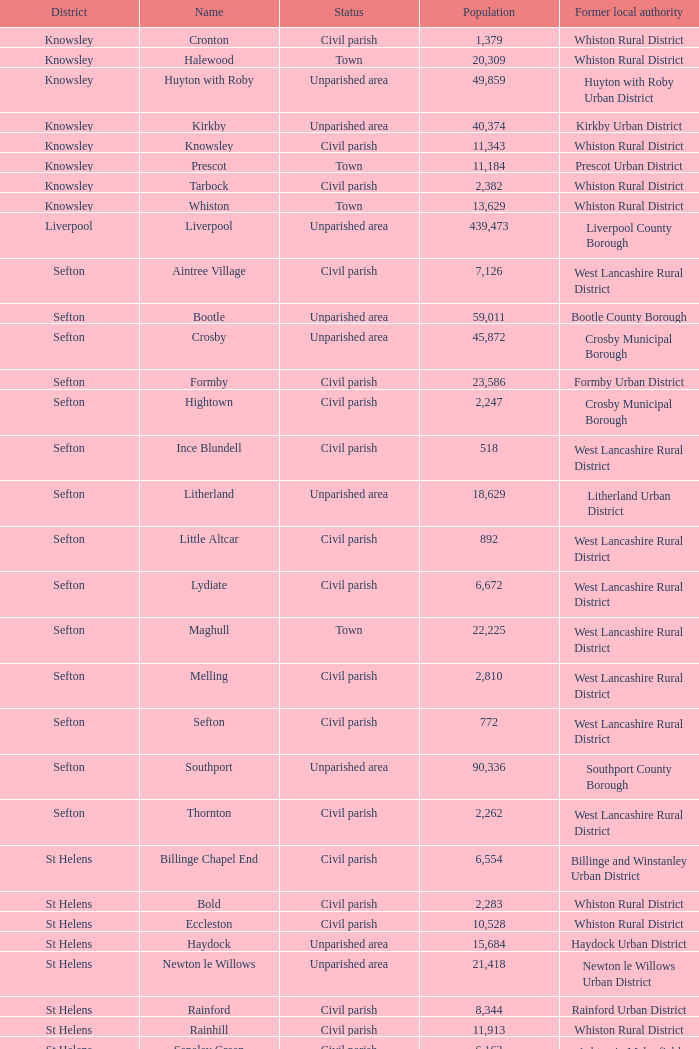What is the district of wallasey Wirral. 